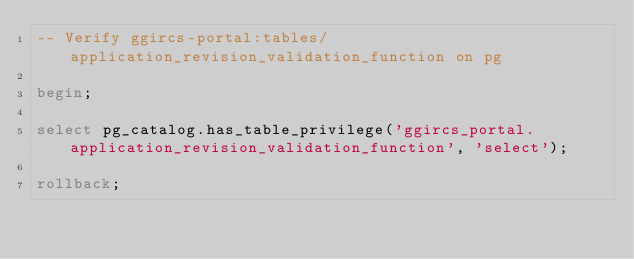Convert code to text. <code><loc_0><loc_0><loc_500><loc_500><_SQL_>-- Verify ggircs-portal:tables/application_revision_validation_function on pg

begin;

select pg_catalog.has_table_privilege('ggircs_portal.application_revision_validation_function', 'select');

rollback;
</code> 